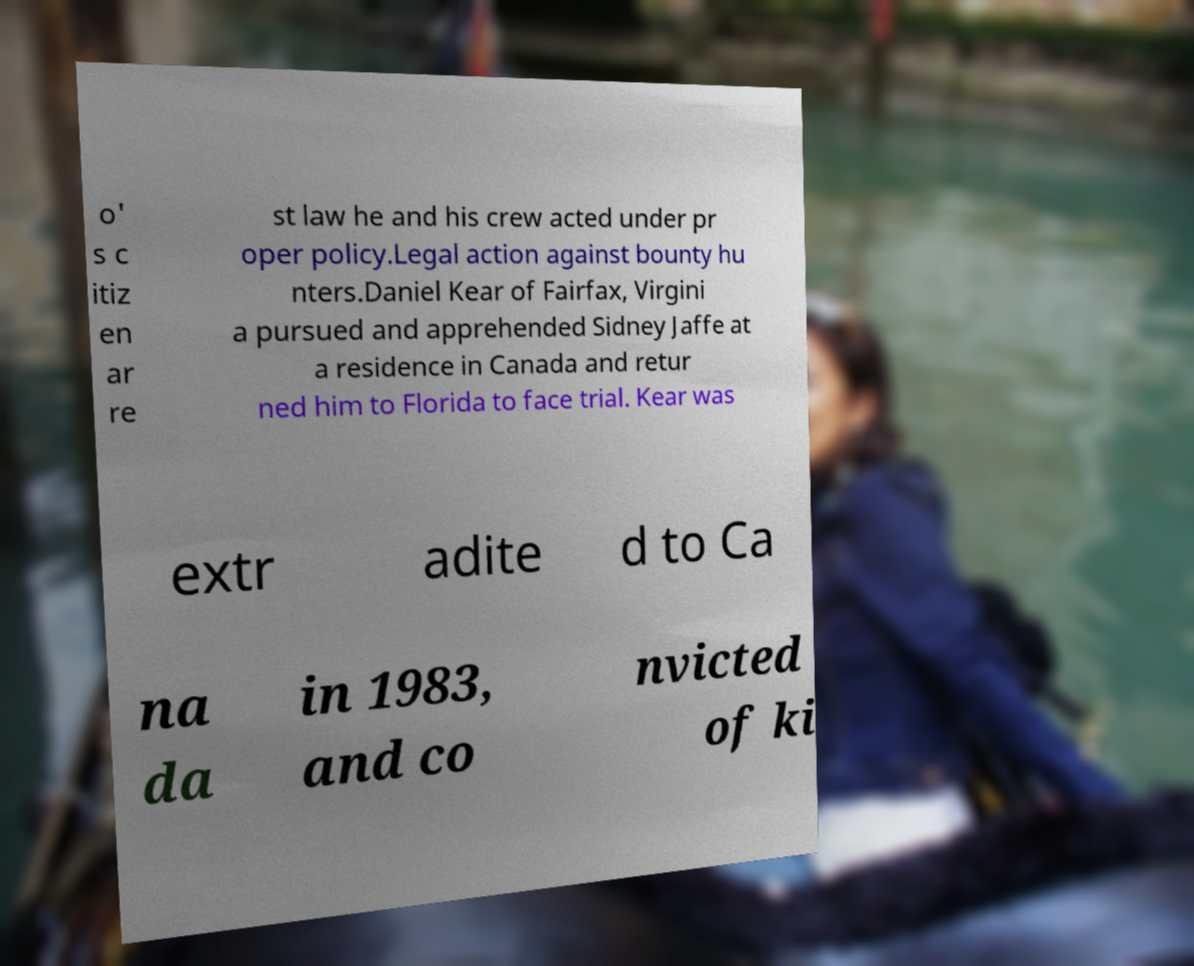For documentation purposes, I need the text within this image transcribed. Could you provide that? o' s c itiz en ar re st law he and his crew acted under pr oper policy.Legal action against bounty hu nters.Daniel Kear of Fairfax, Virgini a pursued and apprehended Sidney Jaffe at a residence in Canada and retur ned him to Florida to face trial. Kear was extr adite d to Ca na da in 1983, and co nvicted of ki 